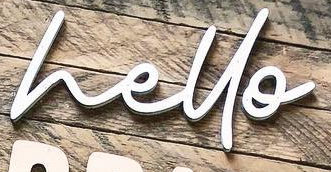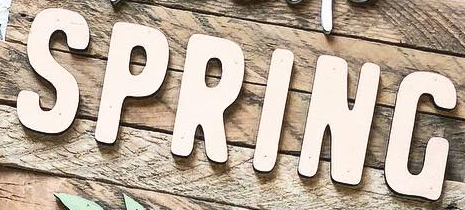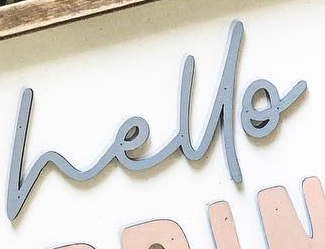Identify the words shown in these images in order, separated by a semicolon. hello; SPRING; hello 